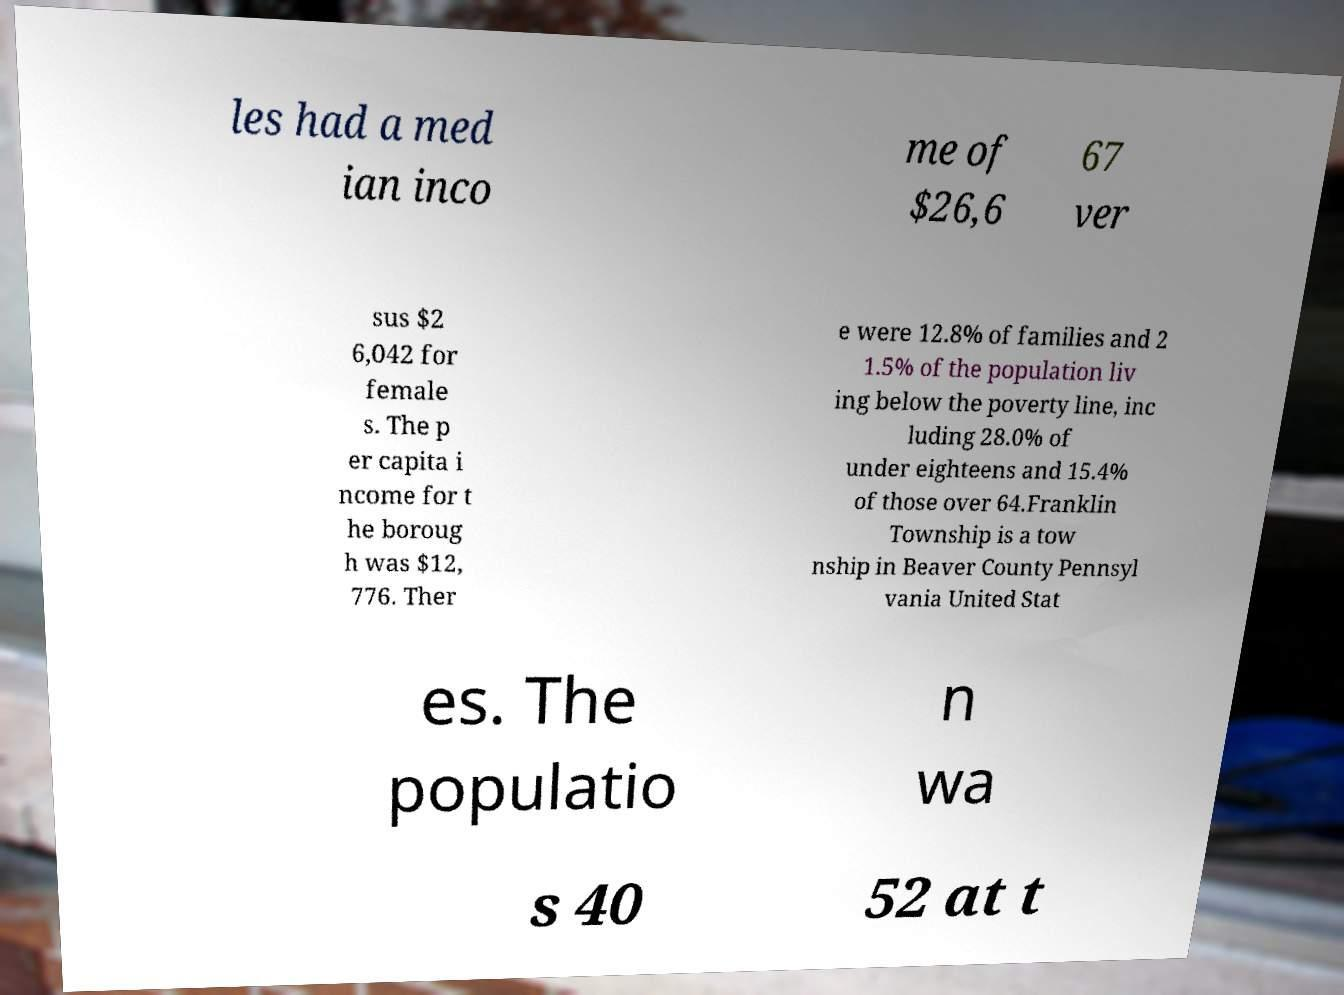Could you extract and type out the text from this image? les had a med ian inco me of $26,6 67 ver sus $2 6,042 for female s. The p er capita i ncome for t he boroug h was $12, 776. Ther e were 12.8% of families and 2 1.5% of the population liv ing below the poverty line, inc luding 28.0% of under eighteens and 15.4% of those over 64.Franklin Township is a tow nship in Beaver County Pennsyl vania United Stat es. The populatio n wa s 40 52 at t 